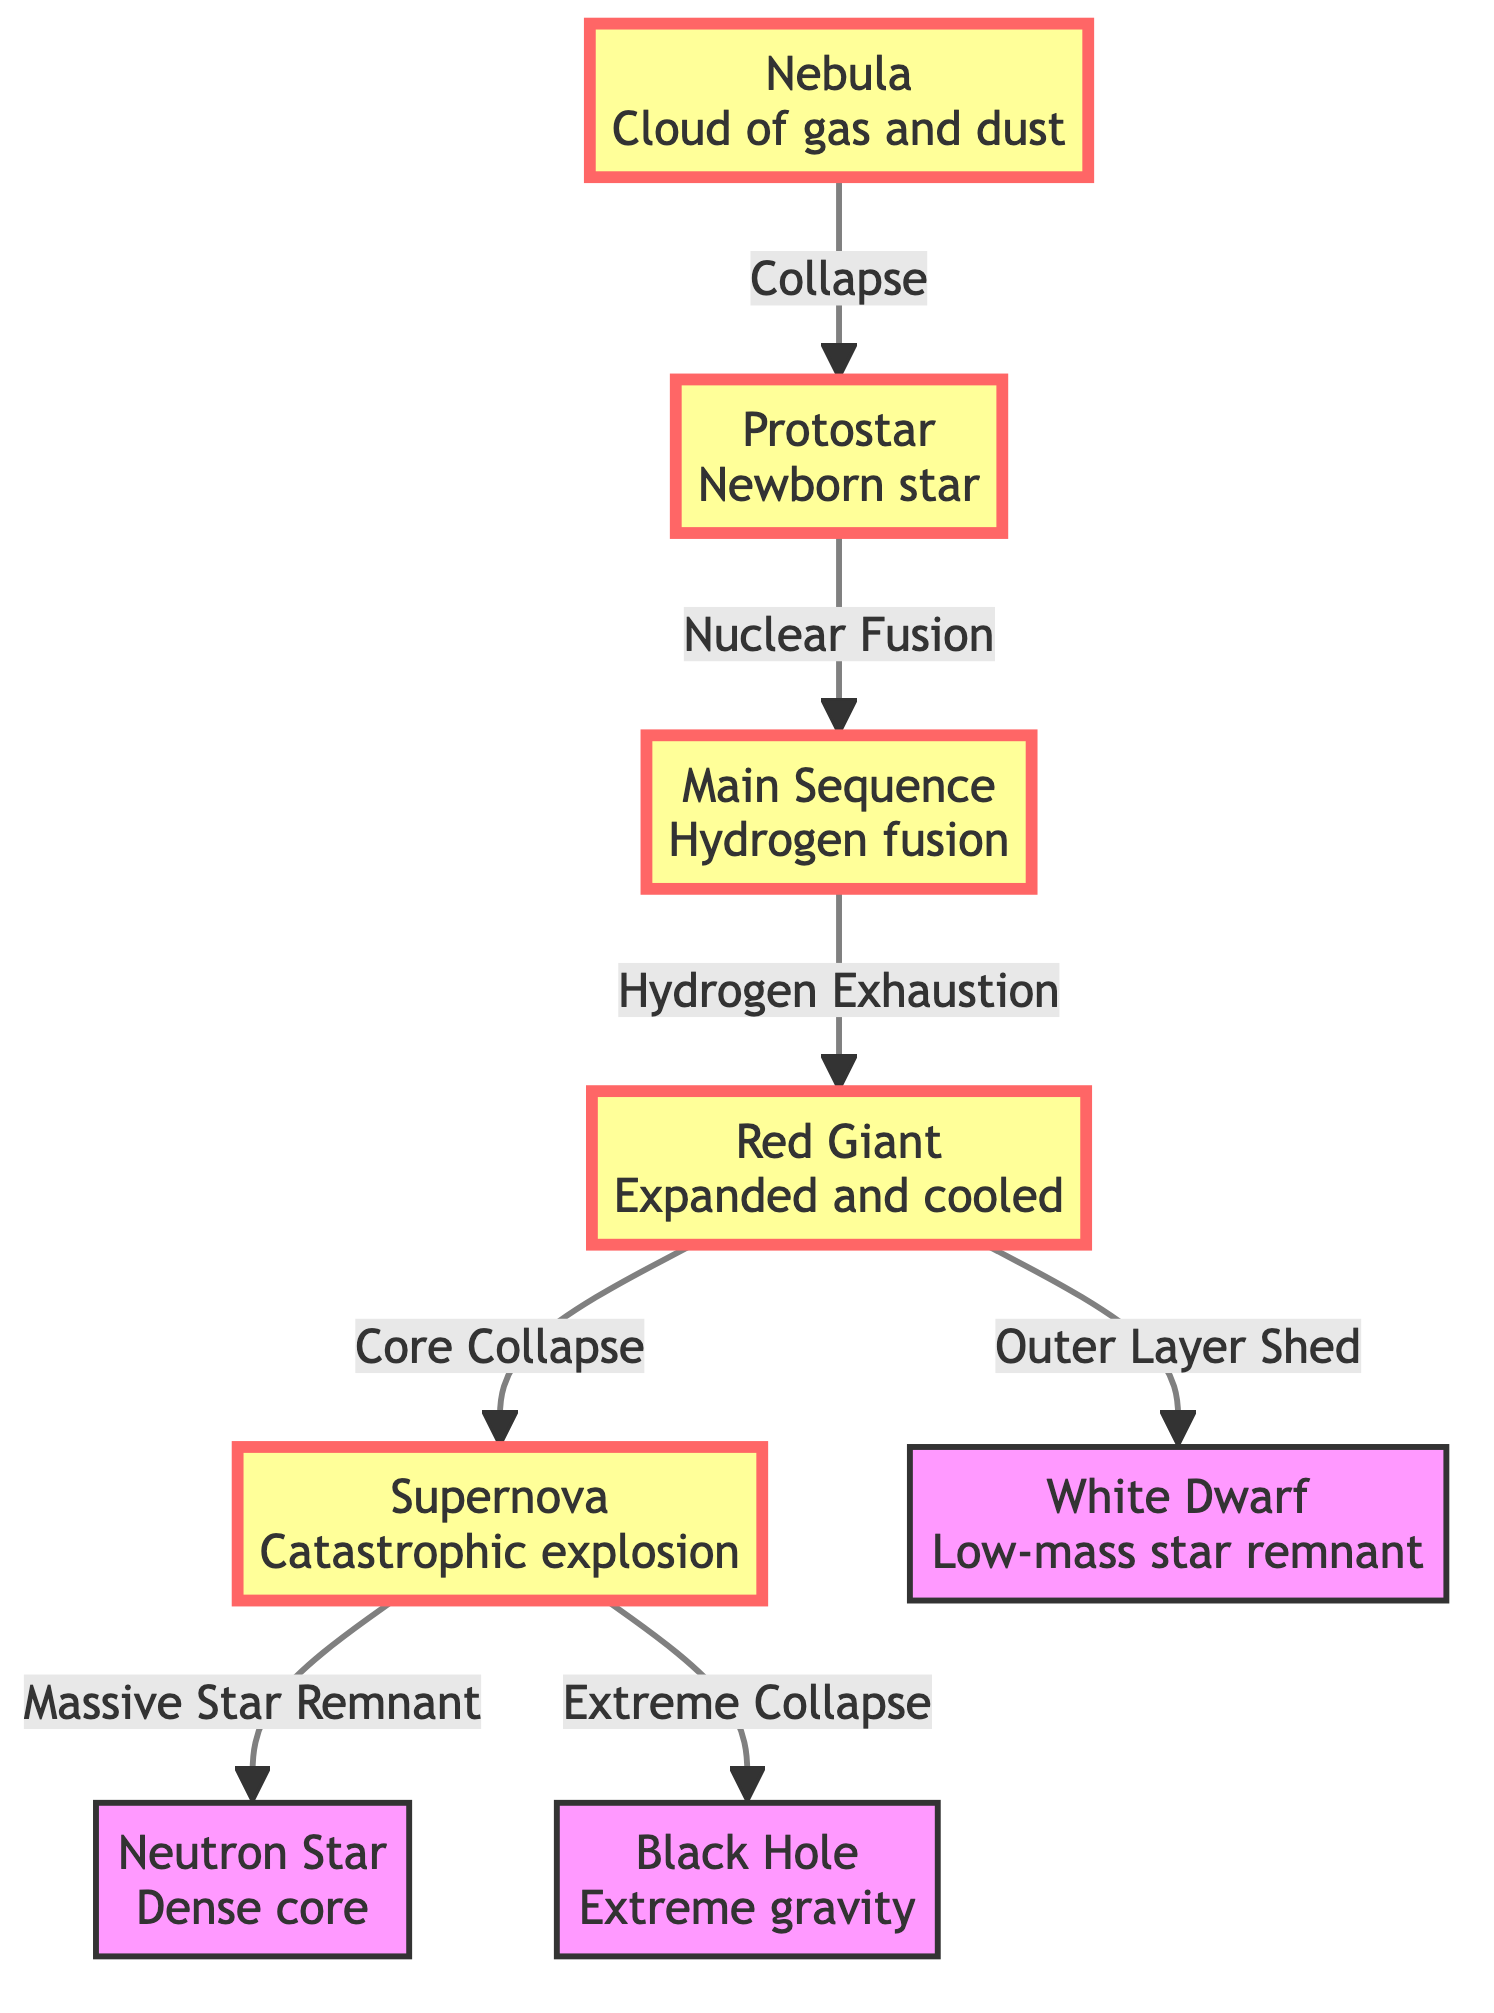What is the first stage of stellar evolution? The first stage of stellar evolution is the nebula, which is depicted at the beginning of the flowchart. It represents a cloud of gas and dust.
Answer: Nebula How many main stages are highlighted in this diagram? The diagram highlights four main stages: nebula, protostar, main sequence, and red giant. These are visually emphasized, indicating their significance in stellar evolution.
Answer: Four What process leads from a protostar to the main sequence? The diagram indicates that the process is nuclear fusion, which occurs as the protostar develops into a stable main sequence star.
Answer: Nuclear Fusion Which type of star is created after the red giant's outer layers are shed? After the red giant sheds its outer layers, it transitions into a white dwarf, as indicated in the flowchart.
Answer: White Dwarf What happens to a massive star after a supernova event? The diagram illustrates that after a supernova event, a massive star can result in either a neutron star or a black hole, depending on the star's mass.
Answer: Neutron Star or Black Hole What is the relationship between the red giant and the white dwarf? A white dwarf is formed from a red giant after it has shed its outer layer, and this relationship is indicated by the directed edge connecting these two nodes in the diagram.
Answer: Outer Layer Shed Which stage comes immediately after the main sequence? According to the flowchart, the stage that immediately follows the main sequence is the red giant, which represents a later evolutionary state of stars.
Answer: Red Giant How does a supernova affect the core of a massive star? The diagram shows that during a supernova, the core of a massive star experiences extreme collapse, which leads to the formation of a neutron star or black hole.
Answer: Extreme Collapse 